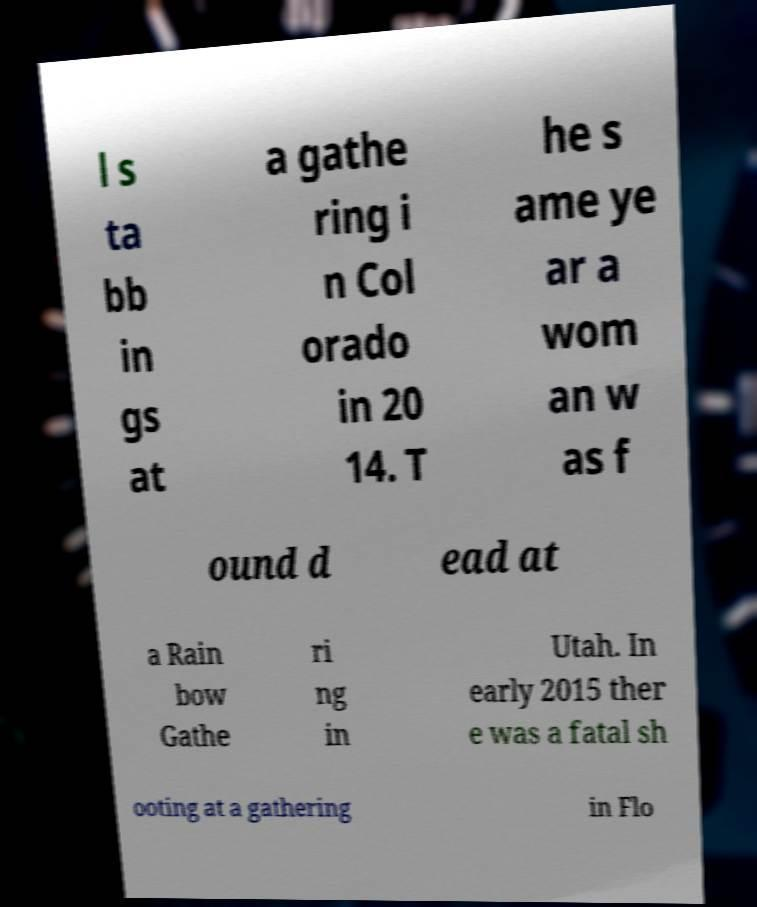Could you extract and type out the text from this image? l s ta bb in gs at a gathe ring i n Col orado in 20 14. T he s ame ye ar a wom an w as f ound d ead at a Rain bow Gathe ri ng in Utah. In early 2015 ther e was a fatal sh ooting at a gathering in Flo 